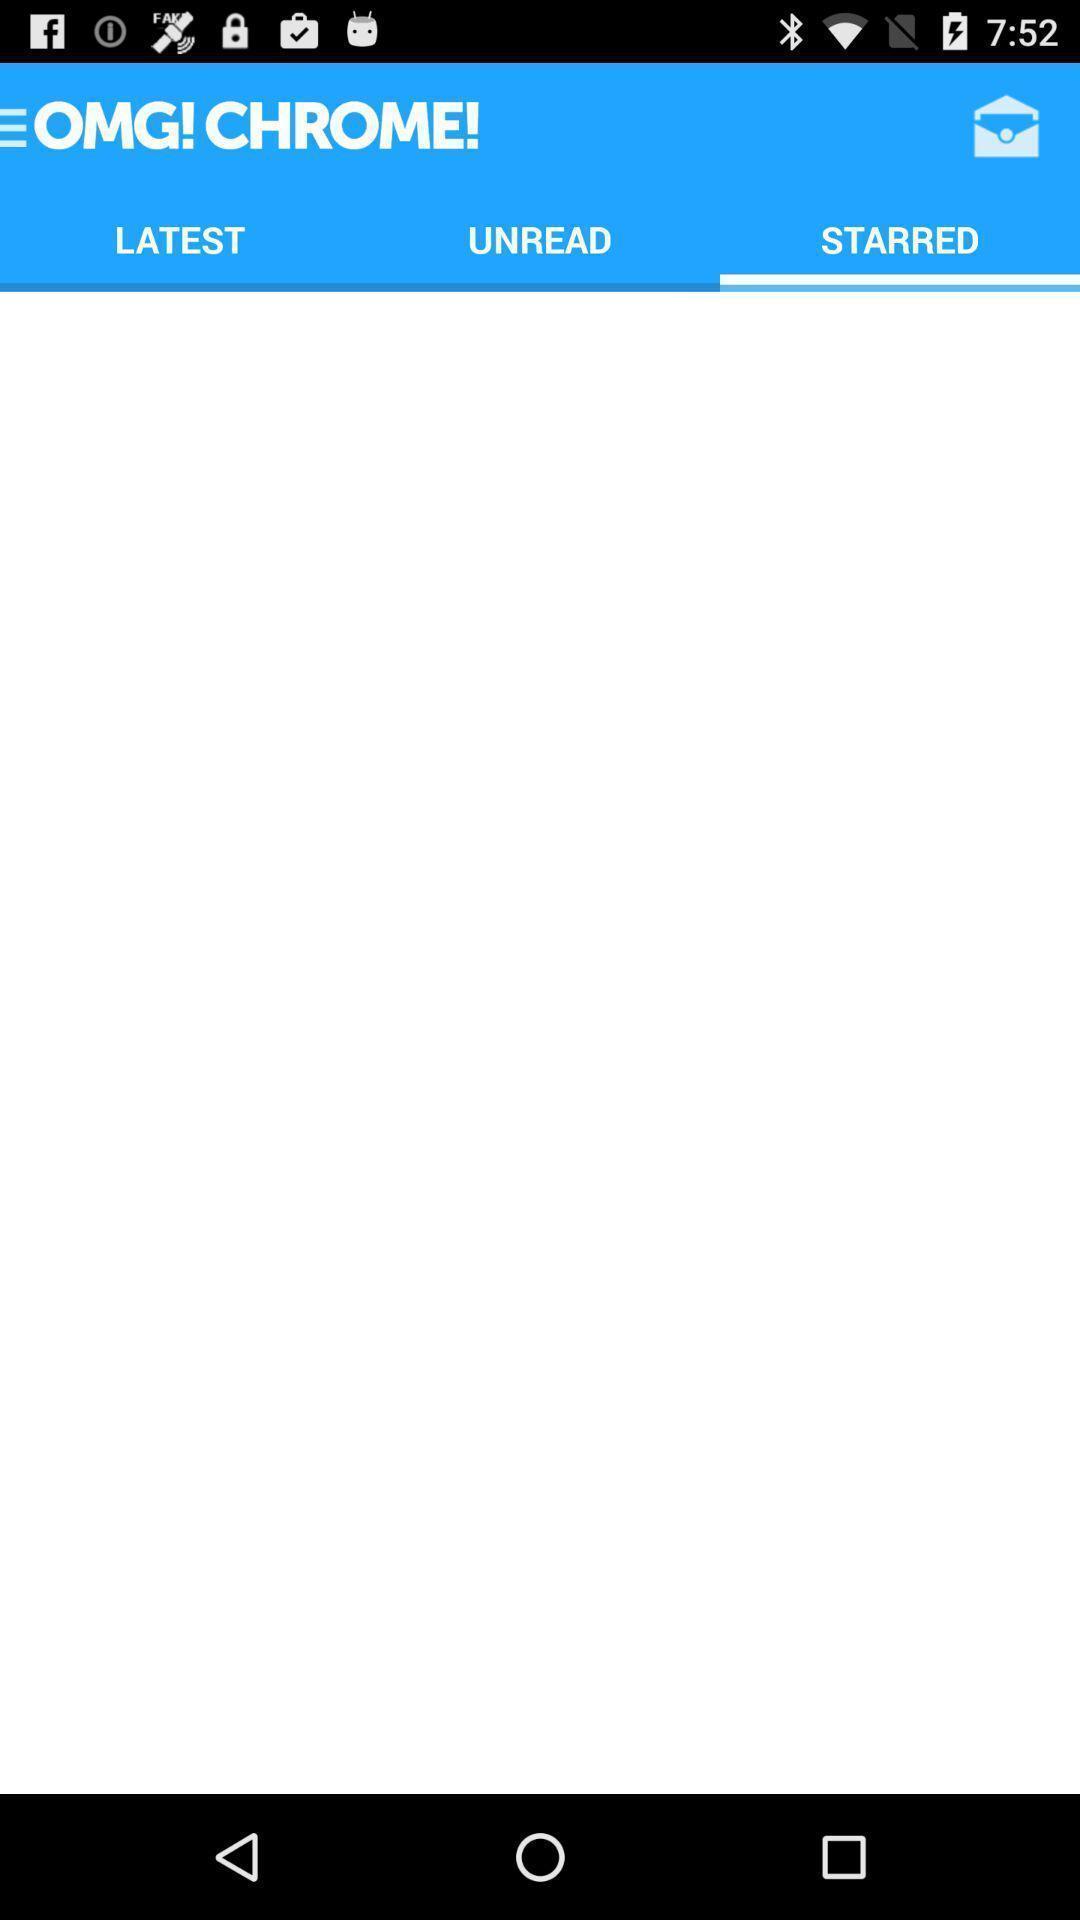Give me a summary of this screen capture. Page shows to list out the starred stories. 